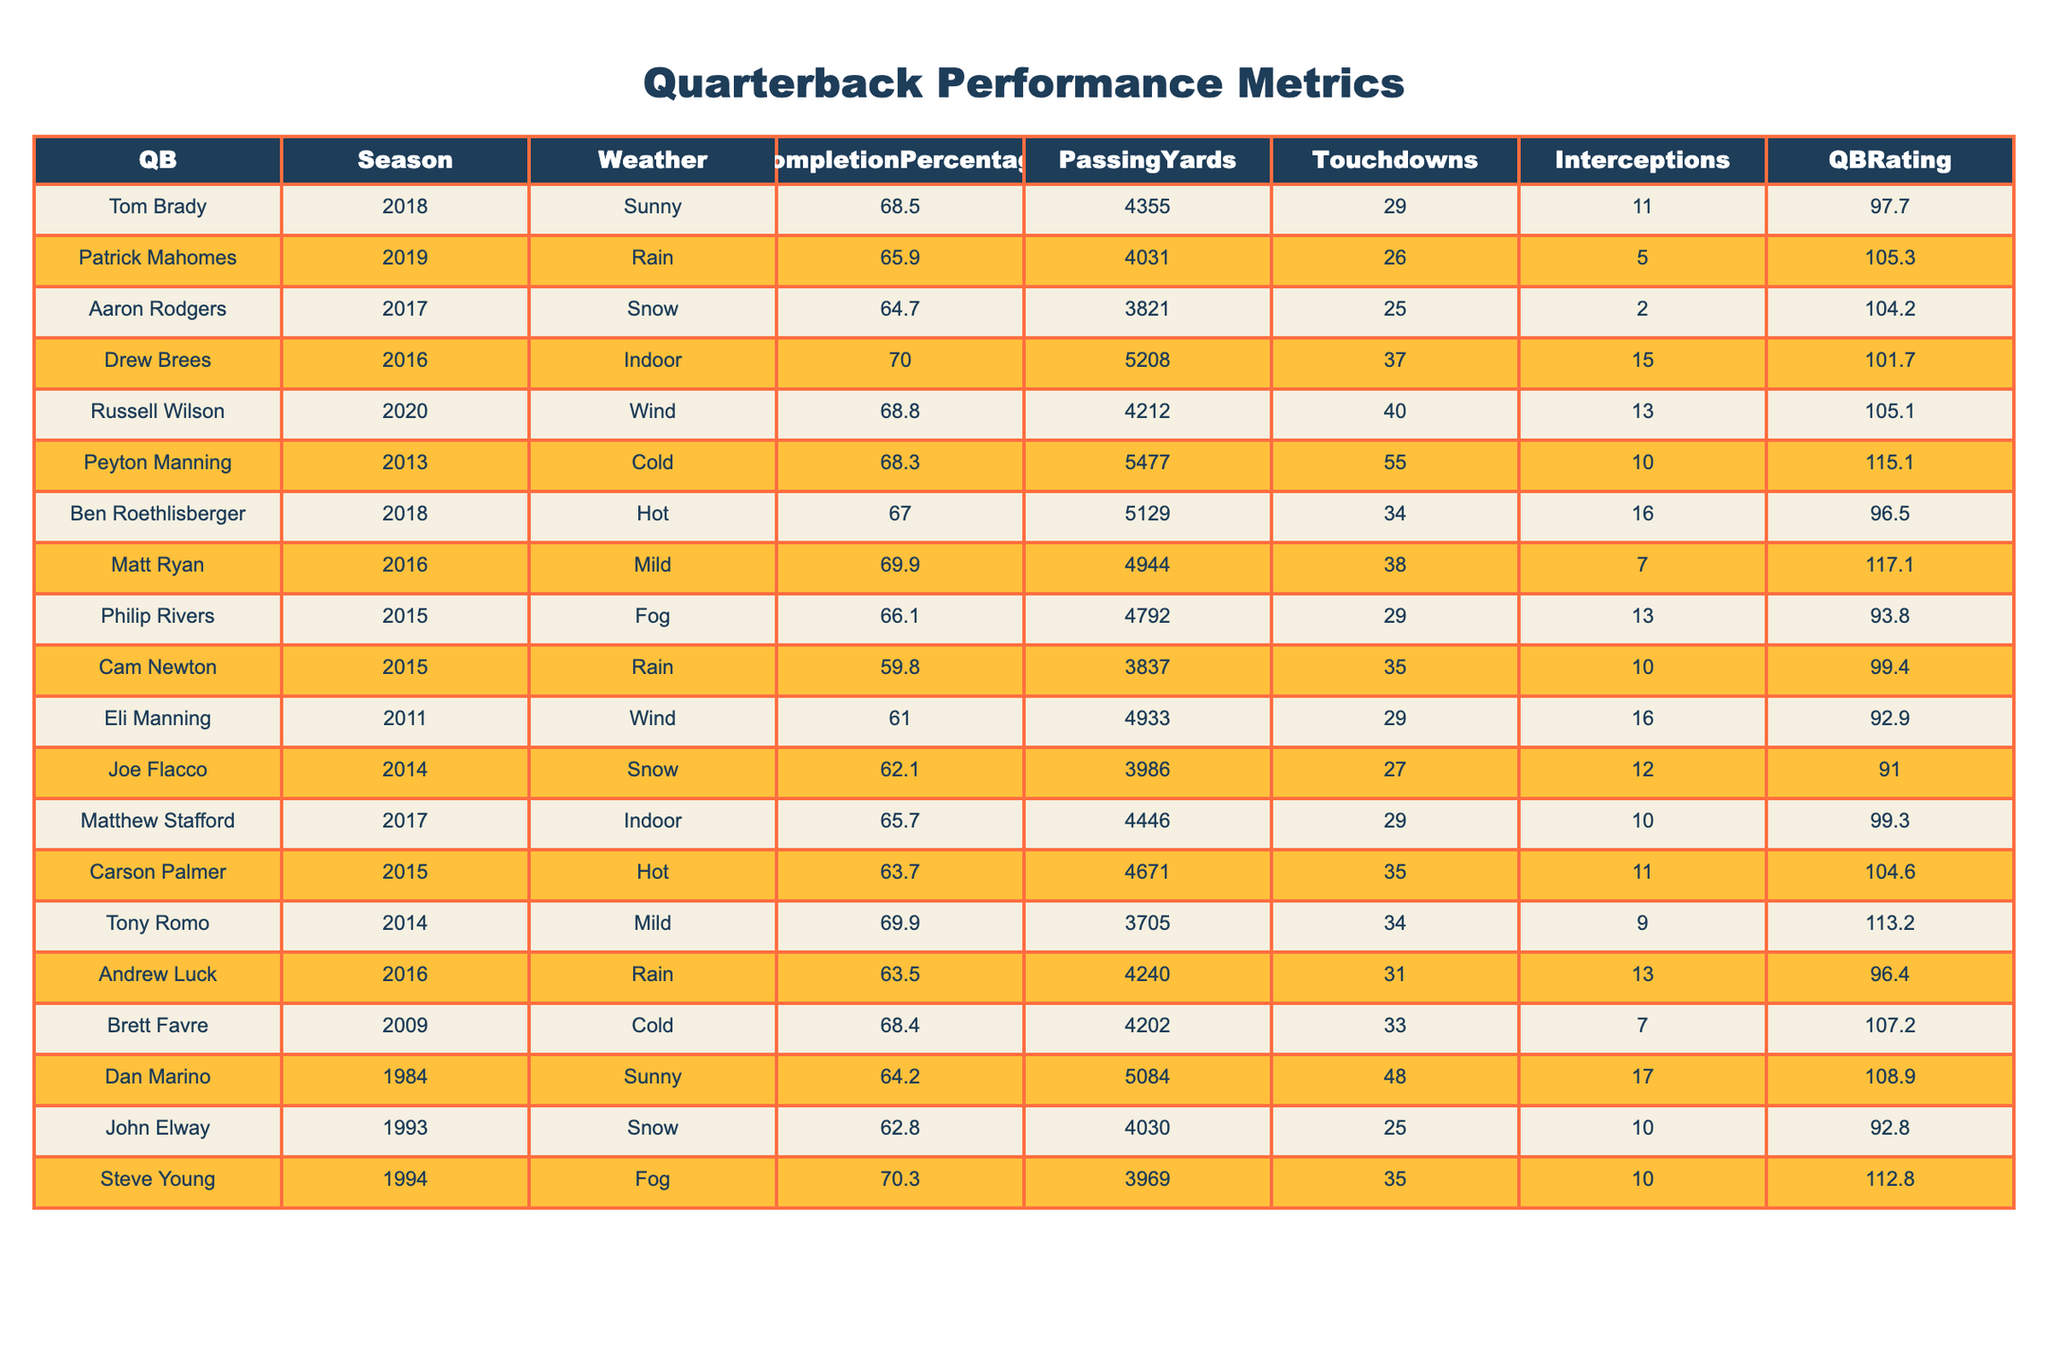What was the completion percentage for Tom Brady in 2018? The table shows that Tom Brady had a completion percentage of 68.5% in the 2018 season.
Answer: 68.5% Which quarterback had the highest passing yards in a single season? Drew Brees had the highest passing yards with 5208 in the 2016 season.
Answer: 5208 How many touchdowns did Patrick Mahomes throw in 2019? According to the table, Patrick Mahomes threw 26 touchdowns during the 2019 season.
Answer: 26 Is it true that Eli Manning had a higher completion percentage than Cam Newton in 2015? Eli Manning's completion percentage was 61.0%, and Cam Newton's was 59.8%, so Eli did have a higher completion percentage than Cam.
Answer: Yes What was the average QBRating for quarterbacks playing in windy conditions? The table shows Eli Manning (92.9), Russell Wilson (105.1), and the average would be (92.9 + 105.1) / 2 = 99.0.
Answer: 99.0 How many interceptions did Ben Roethlisberger throw in the 2018 season compared to Drew Brees in the 2016 season? Ben Roethlisberger threw 16 interceptions, while Drew Brees threw 15 interceptions in their respective seasons.
Answer: Roethlisberger: 16, Brees: 15 Between the cold and rainy weather conditions, which condition resulted in a higher average touchdown total? The quarterbacks in cold weather (Peyton Manning: 55, Brett Favre: 33) average 44, while those in rainy conditions (Andrew Luck: 31, Patrick Mahomes: 26, and Cam Newton: 35) average 30.67.
Answer: Cold weather: 44; Rainy weather: 30.67 What is the difference in completion percentage between the highest and lowest performance in snowy conditions? Aaron Rodgers completed 64.7% in 2017 in snowy conditions, and Joe Flacco completed 62.1% in 2014. The difference is 64.7 - 62.1 = 2.6.
Answer: 2.6 Who had the best QBRating among all the quarterbacks listed and in what season? Peyton Manning had the best QBRating of 115.1 in the 2013 season.
Answer: 115.1 (2013) Calculate the total passing yards for quarterbacks who played in indoor conditions. Drew Brees had 5208 yards and Matthew Stafford had 4446 yards, totaling 5208 + 4446 = 9654.
Answer: 9654 